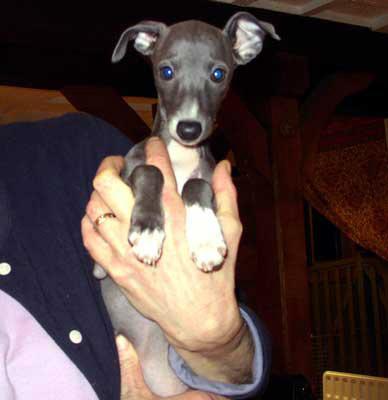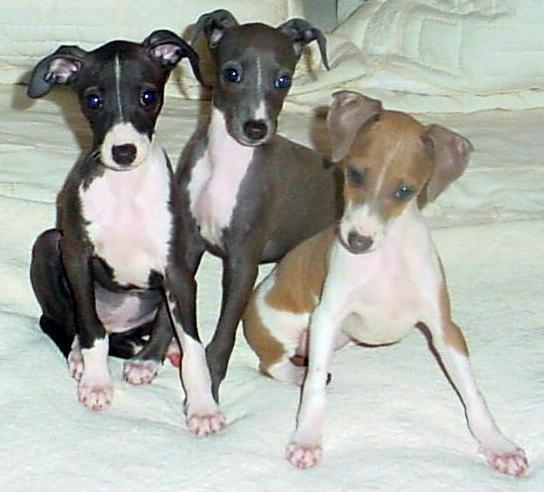The first image is the image on the left, the second image is the image on the right. Assess this claim about the two images: "In total, four dogs are shown.". Correct or not? Answer yes or no. Yes. The first image is the image on the left, the second image is the image on the right. Examine the images to the left and right. Is the description "In one image, a person is holding at least one little dog." accurate? Answer yes or no. Yes. The first image is the image on the left, the second image is the image on the right. Assess this claim about the two images: "An image contains a pair of similarly-posed dogs wearing similar items around their necks.". Correct or not? Answer yes or no. No. The first image is the image on the left, the second image is the image on the right. Considering the images on both sides, is "The right image contains exactly two dogs seated next to each other looking towards the right." valid? Answer yes or no. No. 